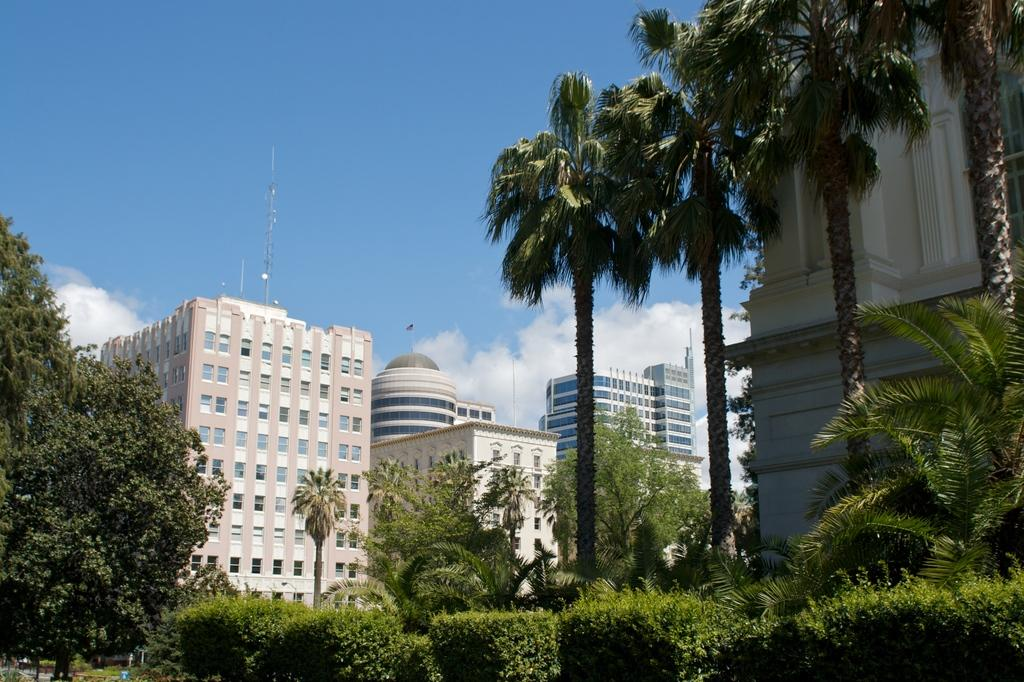What type of natural elements can be seen in the image? There are plants and trees in the image. What man-made structures are present in the image? There are poles and buildings in the image. What is visible in the background of the image? The sky is visible in the background of the image. What can be seen in the sky? There are clouds in the sky. What type of blade is being used to express anger in the image? There is no blade or expression of anger present in the image. 